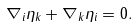Convert formula to latex. <formula><loc_0><loc_0><loc_500><loc_500>\nabla _ { i } \eta _ { k } + \nabla _ { k } \eta _ { i } = 0 .</formula> 